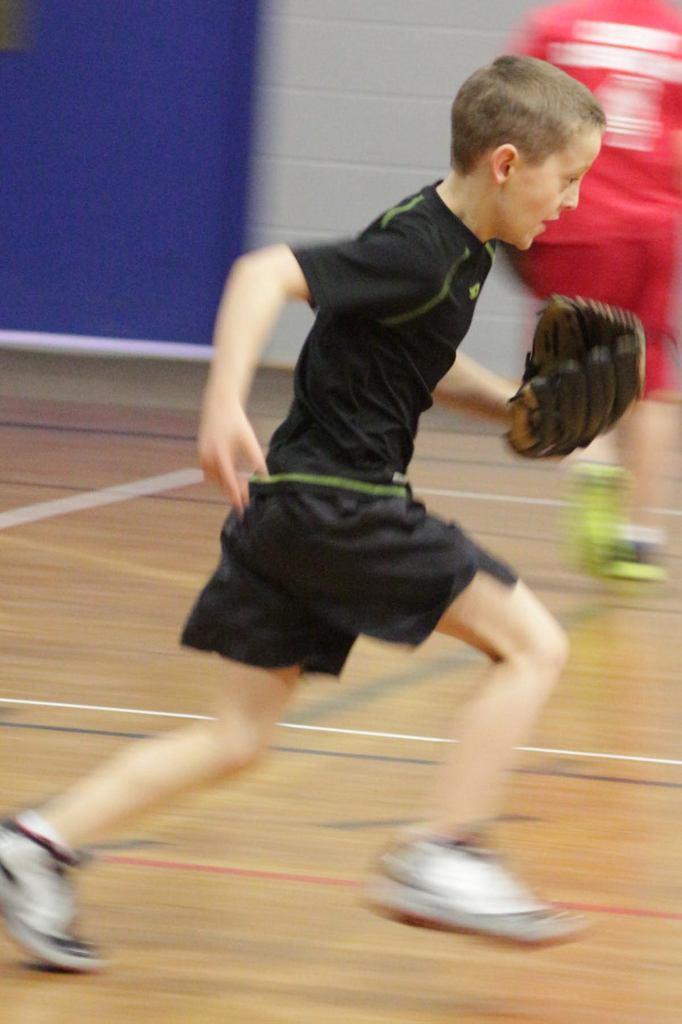How would you summarize this image in a sentence or two? In this image we can see a boy running on the floor. In the background we can see person and wall. 